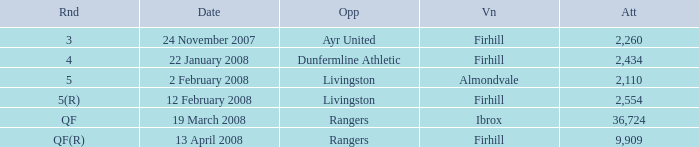Who was the opponent at the qf(r) round? Rangers. 